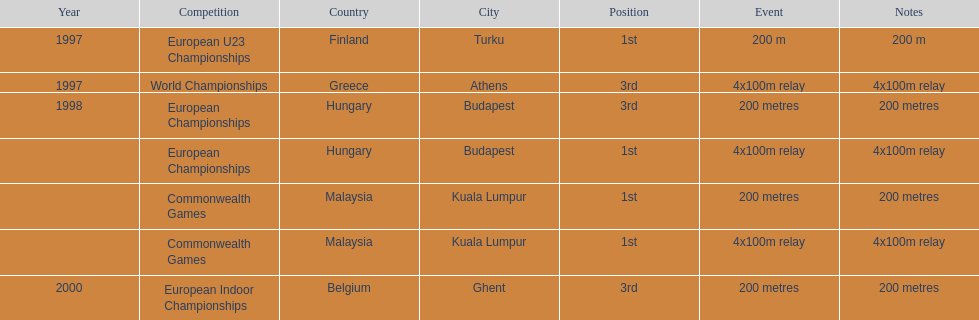How many competitions were in budapest, hungary and came in 1st position? 1. 